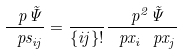<formula> <loc_0><loc_0><loc_500><loc_500>\frac { \ p \tilde { \Psi } } { \ p s _ { i j } } = \frac { } { \{ i j \} ! } \frac { \ p ^ { 2 } \tilde { \Psi } } { \ p x _ { i } \ p x _ { j } }</formula> 